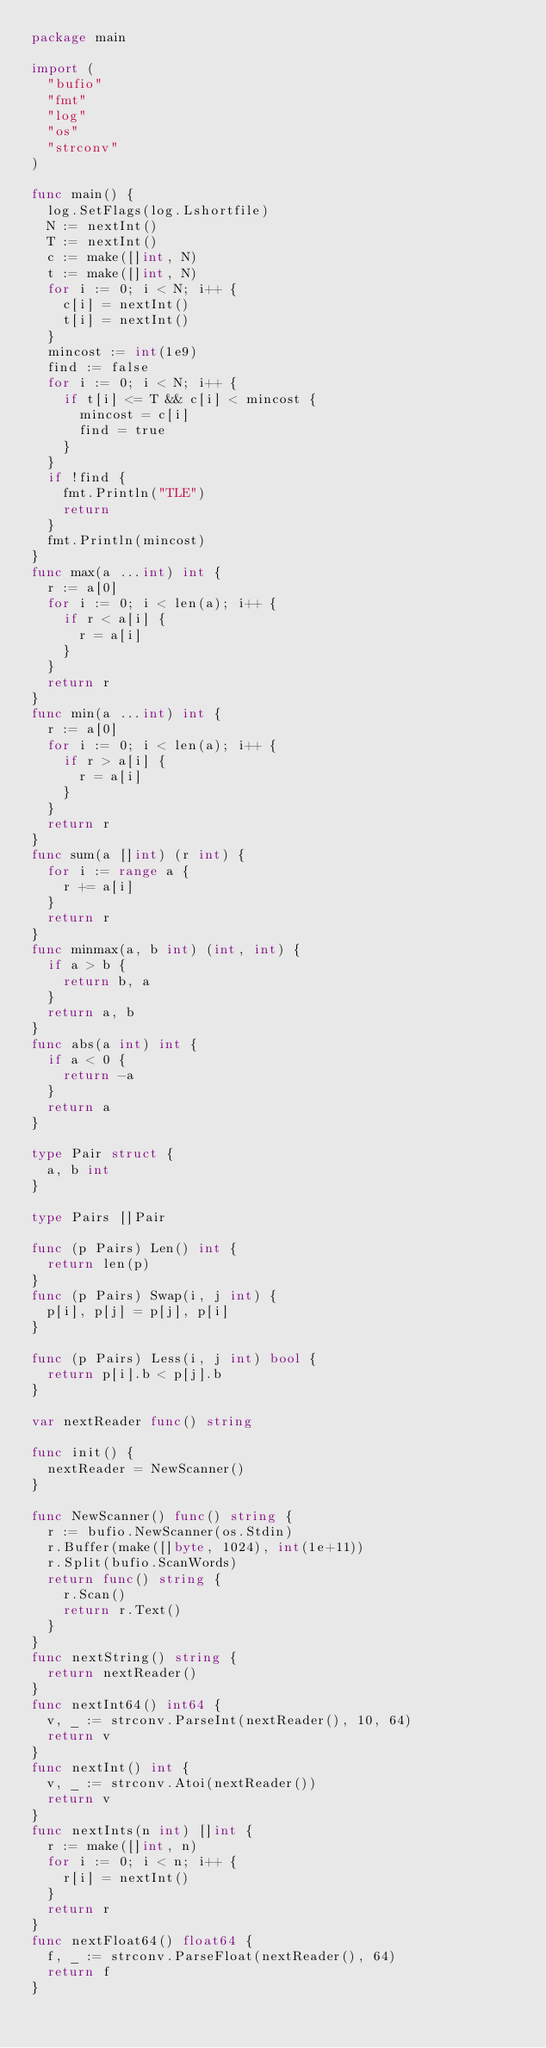Convert code to text. <code><loc_0><loc_0><loc_500><loc_500><_Go_>package main

import (
	"bufio"
	"fmt"
	"log"
	"os"
	"strconv"
)

func main() {
	log.SetFlags(log.Lshortfile)
	N := nextInt()
	T := nextInt()
	c := make([]int, N)
	t := make([]int, N)
	for i := 0; i < N; i++ {
		c[i] = nextInt()
		t[i] = nextInt()
	}
	mincost := int(1e9)
	find := false
	for i := 0; i < N; i++ {
		if t[i] <= T && c[i] < mincost {
			mincost = c[i]
			find = true
		}
	}
	if !find {
		fmt.Println("TLE")
		return
	}
	fmt.Println(mincost)
}
func max(a ...int) int {
	r := a[0]
	for i := 0; i < len(a); i++ {
		if r < a[i] {
			r = a[i]
		}
	}
	return r
}
func min(a ...int) int {
	r := a[0]
	for i := 0; i < len(a); i++ {
		if r > a[i] {
			r = a[i]
		}
	}
	return r
}
func sum(a []int) (r int) {
	for i := range a {
		r += a[i]
	}
	return r
}
func minmax(a, b int) (int, int) {
	if a > b {
		return b, a
	}
	return a, b
}
func abs(a int) int {
	if a < 0 {
		return -a
	}
	return a
}

type Pair struct {
	a, b int
}

type Pairs []Pair

func (p Pairs) Len() int {
	return len(p)
}
func (p Pairs) Swap(i, j int) {
	p[i], p[j] = p[j], p[i]
}

func (p Pairs) Less(i, j int) bool {
	return p[i].b < p[j].b
}

var nextReader func() string

func init() {
	nextReader = NewScanner()
}

func NewScanner() func() string {
	r := bufio.NewScanner(os.Stdin)
	r.Buffer(make([]byte, 1024), int(1e+11))
	r.Split(bufio.ScanWords)
	return func() string {
		r.Scan()
		return r.Text()
	}
}
func nextString() string {
	return nextReader()
}
func nextInt64() int64 {
	v, _ := strconv.ParseInt(nextReader(), 10, 64)
	return v
}
func nextInt() int {
	v, _ := strconv.Atoi(nextReader())
	return v
}
func nextInts(n int) []int {
	r := make([]int, n)
	for i := 0; i < n; i++ {
		r[i] = nextInt()
	}
	return r
}
func nextFloat64() float64 {
	f, _ := strconv.ParseFloat(nextReader(), 64)
	return f
}
</code> 